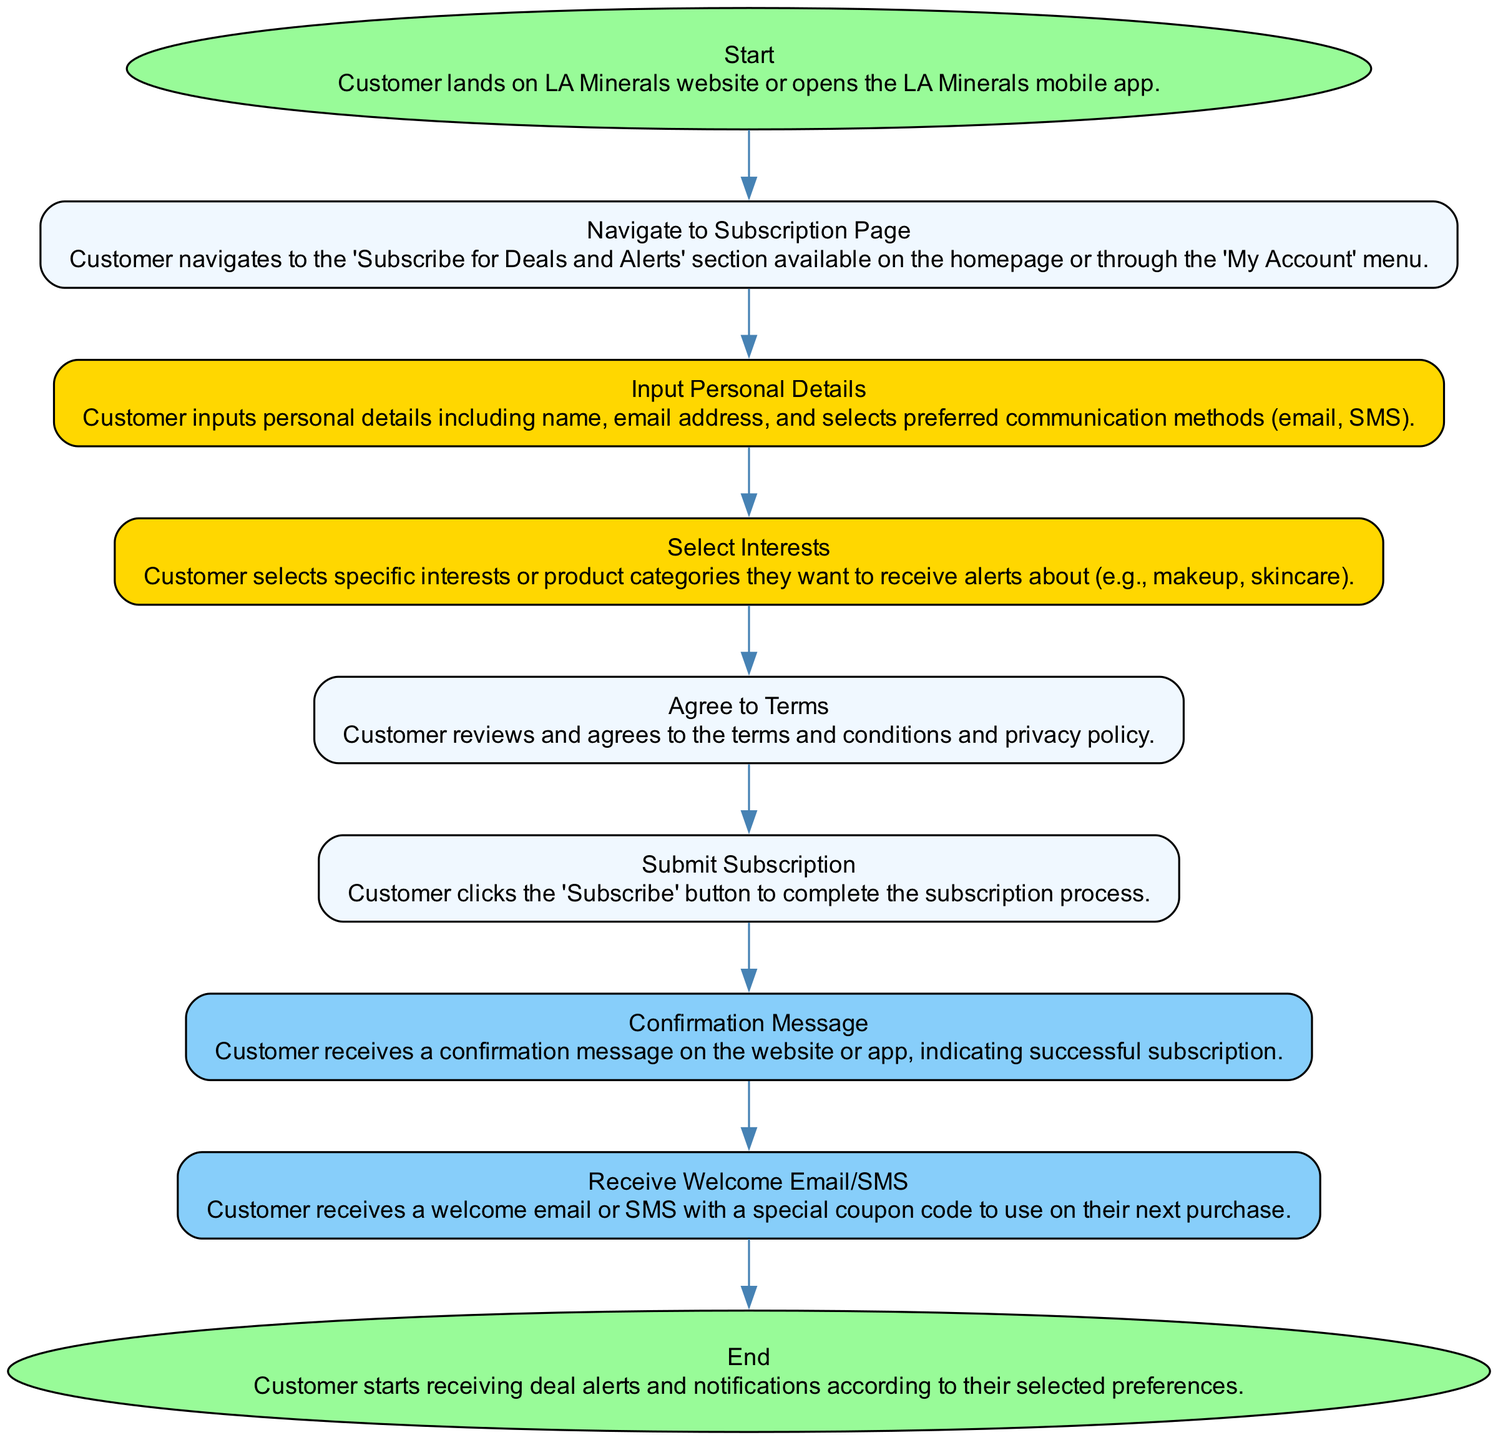What is the starting point of the workflow? The diagram begins with the 'Start' step where the customer lands on the LA Minerals website or opens the LA Minerals mobile app. This is the only step labeled as 'Start'.
Answer: Start How many steps are in the subscription process? By counting all the entries listed in the diagram, there are a total of nine steps from 'Start' to 'End'.
Answer: Nine What action does the customer take after agreeing to the terms? After agreeing to the terms and conditions, the customer proceeds to submit their subscription by clicking the 'Subscribe' button. This is the next step following 'Agree to Terms'.
Answer: Submit Subscription What type of message do customers receive after submitting their subscription? After the subscription is submitted, the customer receives a confirmation message, which indicates that their subscription was successful. This follows the 'Submit Subscription' step directly.
Answer: Confirmation Message What happens immediately after the confirmation message? Immediately after the confirmation message, the customer receives a welcome email or SMS, which includes a special coupon code for their next purchase. This follows the 'Confirmation Message' step.
Answer: Receive Welcome Email/SMS Which step involves selecting product categories? The step where the customer selects specific interests or product categories occurs immediately after inputting their personal details. This step is labeled 'Select Interests'.
Answer: Select Interests What is indicated at the end of the workflow? At the 'End' of the workflow, it is indicated that customers will start receiving deal alerts and notifications based on their chosen preferences during the subscription process.
Answer: Start receiving deal alerts and notifications What does the welcome message include? The welcome email or SMS that customers receive includes a special coupon code to use at their next purchase, making it a promotional benefit of subscribing.
Answer: Special coupon code What color represents the 'End' step in the diagram? The 'End' step is represented in a green color, specifically filled with '#98fb98', which is designated for both the 'Start' and 'End' steps in the diagram design.
Answer: Green 